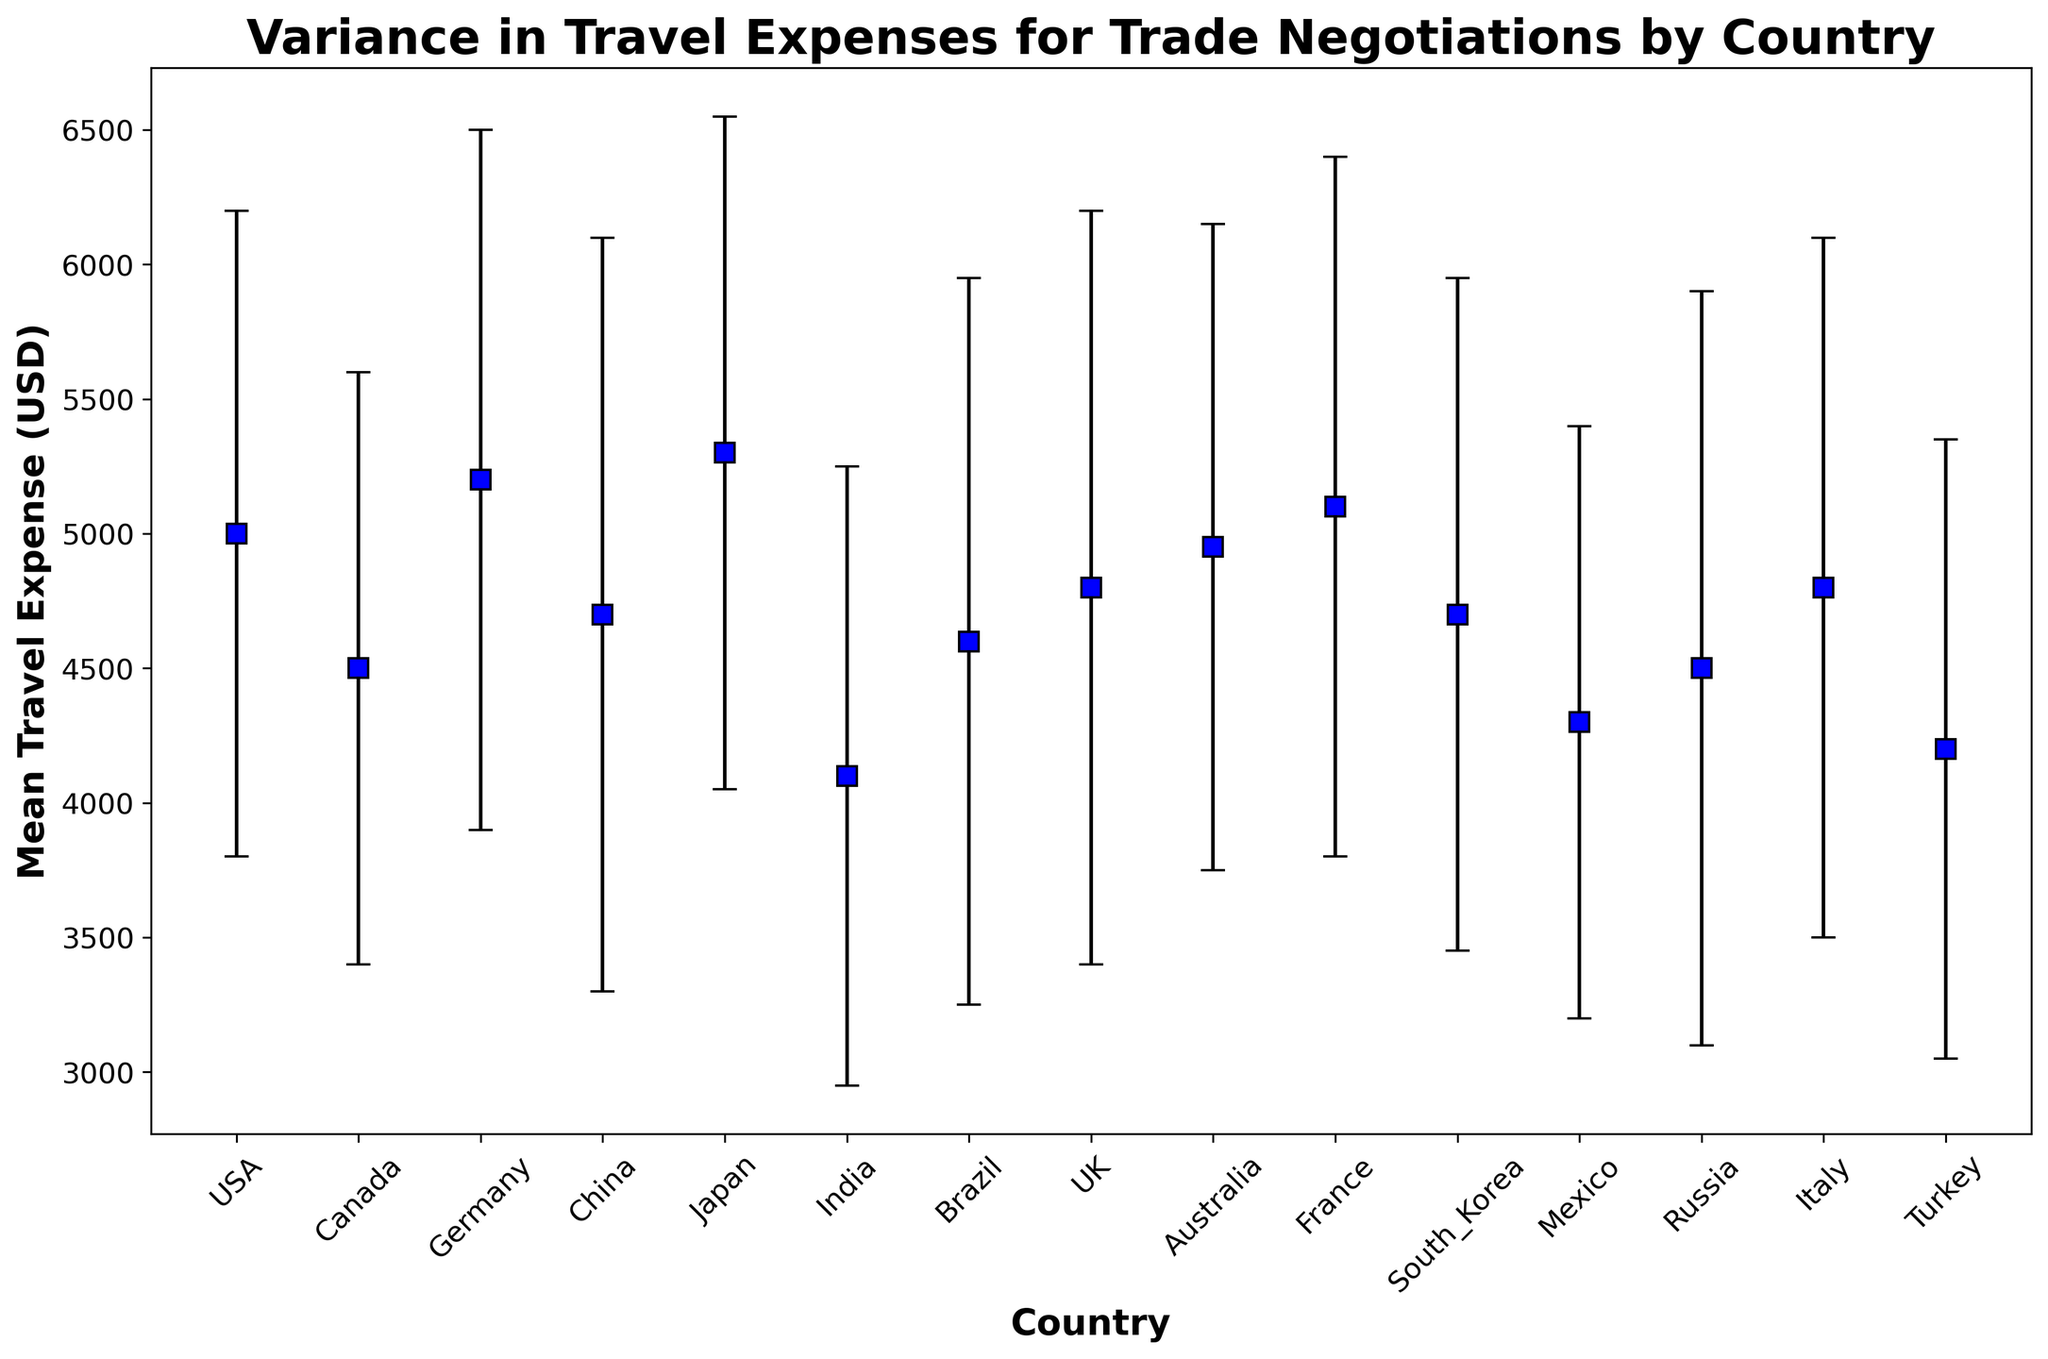Which country has the highest mean travel expense? Look for the country with the highest mean travel expense value on the y-axis. Japan has the highest mean travel expense at $5300.
Answer: Japan Which country has the lowest mean travel expense? Look for the country with the lowest mean travel expense value on the y-axis. India has the lowest mean travel expense at $4100.
Answer: India What is the difference between the highest and lowest mean travel expenses? The highest mean travel expense is $5300 (Japan) and the lowest is $4100 (India). The difference is $5300 - $4100 = $1200.
Answer: $1200 Which countries have a mean travel expense greater than $5000? Identify the countries with mean travel expenses higher than $5000. The countries are Germany ($5200), Japan ($5300), and France ($5100).
Answer: Germany, Japan, France Which country has the greatest variance in travel expenses? The variance can be approximated by looking for the largest standard deviation. China and the UK both have the highest standard deviation of $1400.
Answer: China, UK How does the mean travel expense of Brazil compare to that of Mexico? Examine the mean travel expenses for both countries. Brazil’s mean travel expense is $4600 while Mexico’s is $4300. Brazil’s mean travel expense is higher.
Answer: Brazil’s mean expense is higher Which country has a mean travel expense closest to $5000? Find the country with a mean travel expense most proximate to $5000. Australia has a mean expense of $4950, which is the closest to $5000.
Answer: Australia What is the average mean travel expense for all the countries? Sum the mean travel expenses for all countries and divide by the number of countries. Total mean expense is 69200, and there are 15 countries, so 69200 / 15 = $4613.33.
Answer: $4613.33 Which countries have a standard deviation of $1300? Identify the countries with a standard deviation exactly at $1300. Germany, France, and Italy have a standard deviation of $1300.
Answer: Germany, France, Italy Is the mean travel expense for USA greater than the mean travel expense for Canada? Compare the mean travel expense values for USA ($5000) and Canada ($4500). The USA’s mean travel expense is greater.
Answer: Yes 